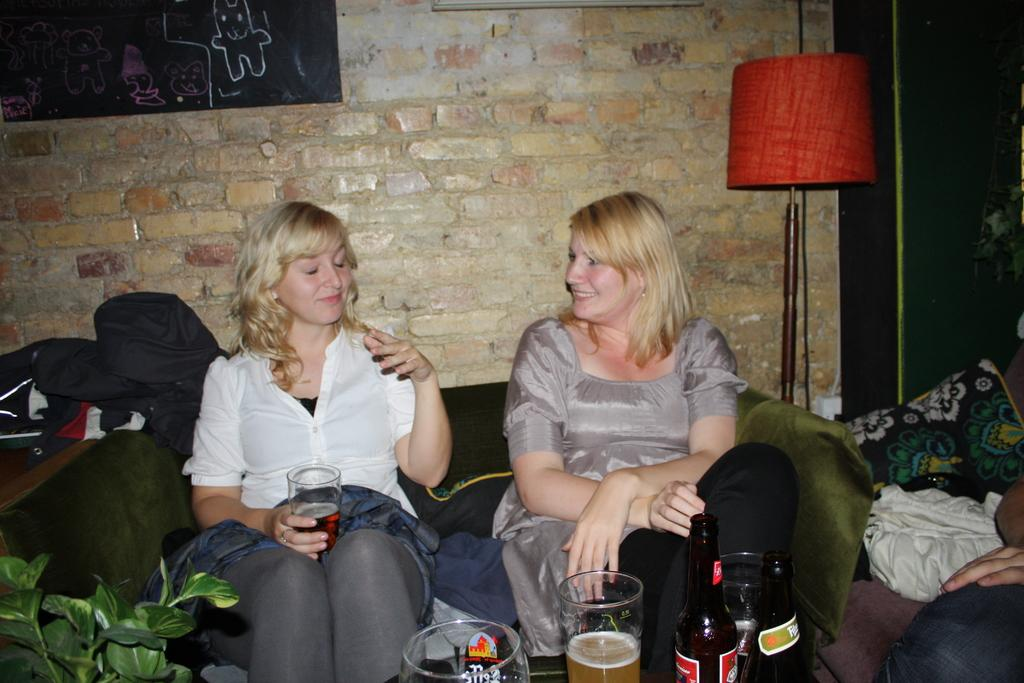What type of structure is visible in the image? There is a brick wall in the image. What is the color of the board in the image? There is a black color board in the image. What object provides light in the image? There is a lamp in the image. How many people are sitting on sofas in the image? There are two people sitting on sofas in the image. What objects are in the front of the image? There are glasses and a bottle in the front of the image. What type of fowl is sitting on the lamp in the image? There is no fowl present in the image; it only features a brick wall, a black color board, a lamp, two people sitting on sofas, glasses, and a bottle. How does the lamp feel about the people sitting on the sofas in the image? The lamp is an inanimate object and does not have feelings or opinions, so it cannot hate or like anything. 